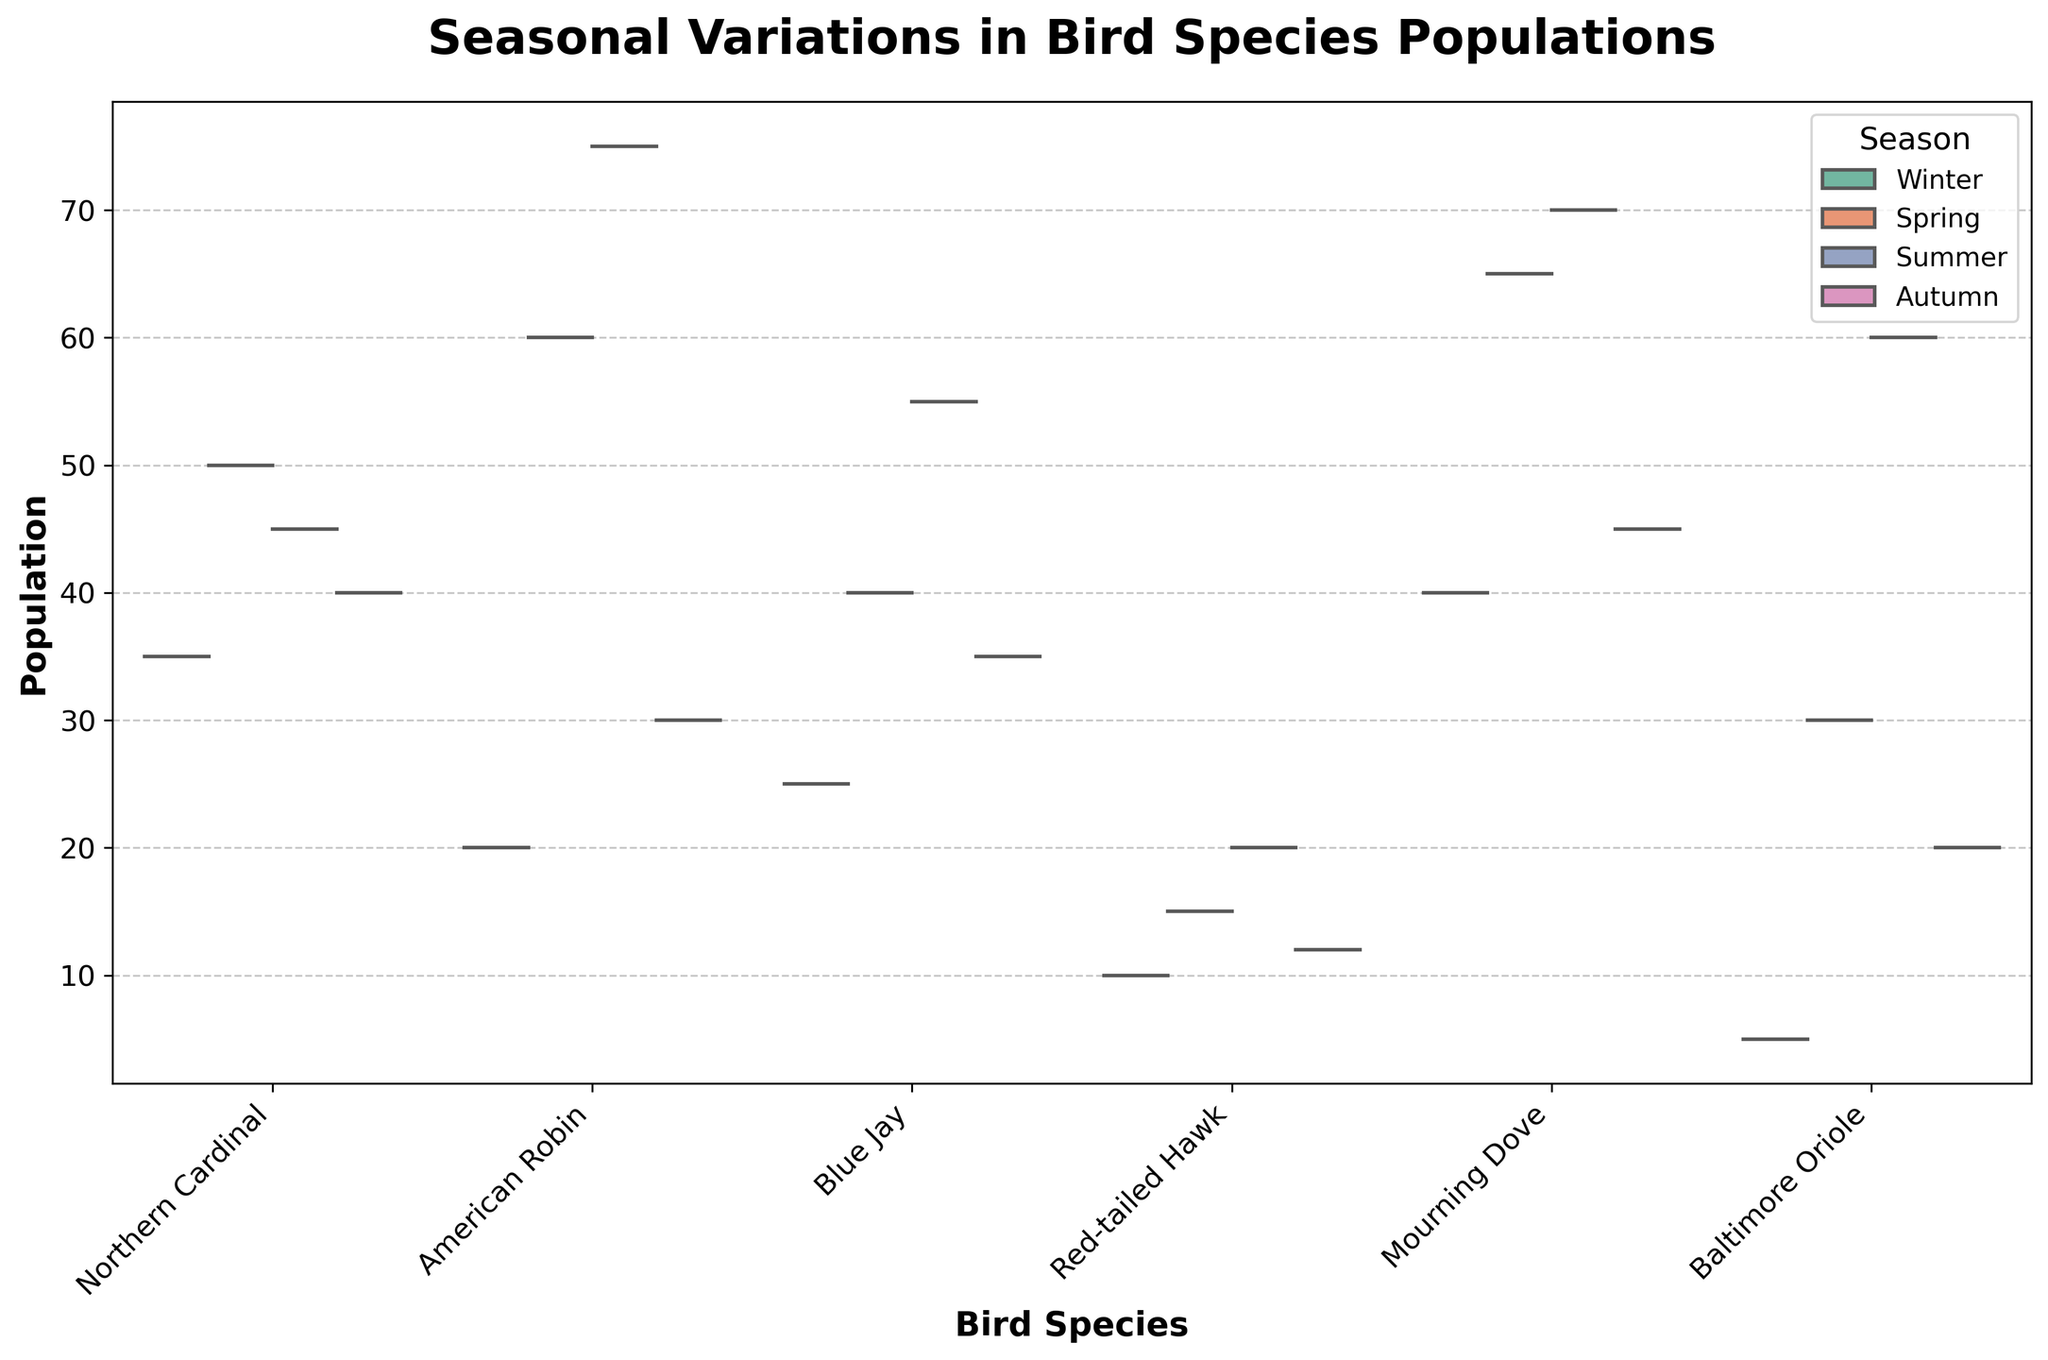What's the title of the plot? The title is located at the top of the plot. It reads "Seasonal Variations in Bird Species Populations".
Answer: Seasonal Variations in Bird Species Populations Which bird species has the highest population in Spring? By observing the split violin plot, we see the part corresponding to "Mourning Dove" has the highest peak in Spring compared to others.
Answer: Mourning Dove What is the median population of the Blue Jay during Summer? The inner quartile lines show the median. For Blue Jay in Summer, locate the central peak where the inner lines intersect.
Answer: 55 How does the Winter population of Northern Cardinal compare to that in Summer? By comparing the split portions of the violin for Winter and Summer, it’s clear that Summer’s distribution is higher than Winter’s. Specifically, Winter is 35 and Summer is 45.
Answer: Winter is lower than Summer Which bird species shows the least variation in population across all seasons? Variation can be judged by the width and spread of the violin plots. The Red-tailed Hawk shows the least spread.
Answer: Red-tailed Hawk What is the difference in the peak populations of the American Robin between Spring and Autumn? Identify the peaks: Spring hits 60, and Autumn is at 30. The difference is 60 - 30.
Answer: 30 Which season shows the highest population of Baltimore Oriole? By looking at the highest peak segment for Baltimore Oriole, the Summer season is the highest.
Answer: Summer Between the American Robin and Blue Jay, which species has a higher population in Winter? Compare the Winter regions in the split violin plot for American Robin (20) and Blue Jay (25).
Answer: Blue Jay Which species has the most significant population drop from Summer to Autumn? Identify the peaks for Summer and Autumn for each species, then calculate the differences. Baltimore Oriole drops from 60 to 20.
Answer: Baltimore Oriole Is the median population of Mourning Dove greater in Spring or Autumn? Compare the median lines within the split violins of Spring (65) and Autumn (45) for Mourning Dove.
Answer: Spring 